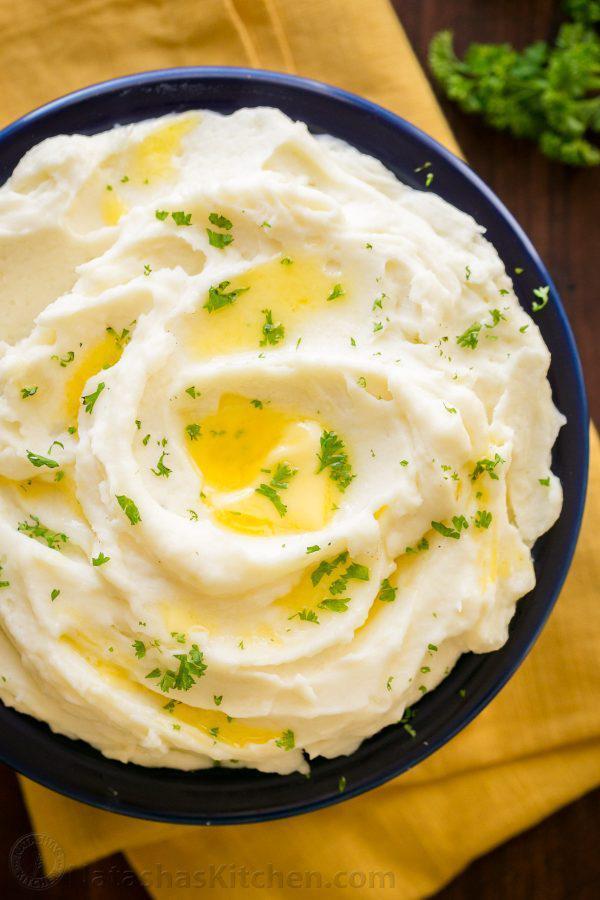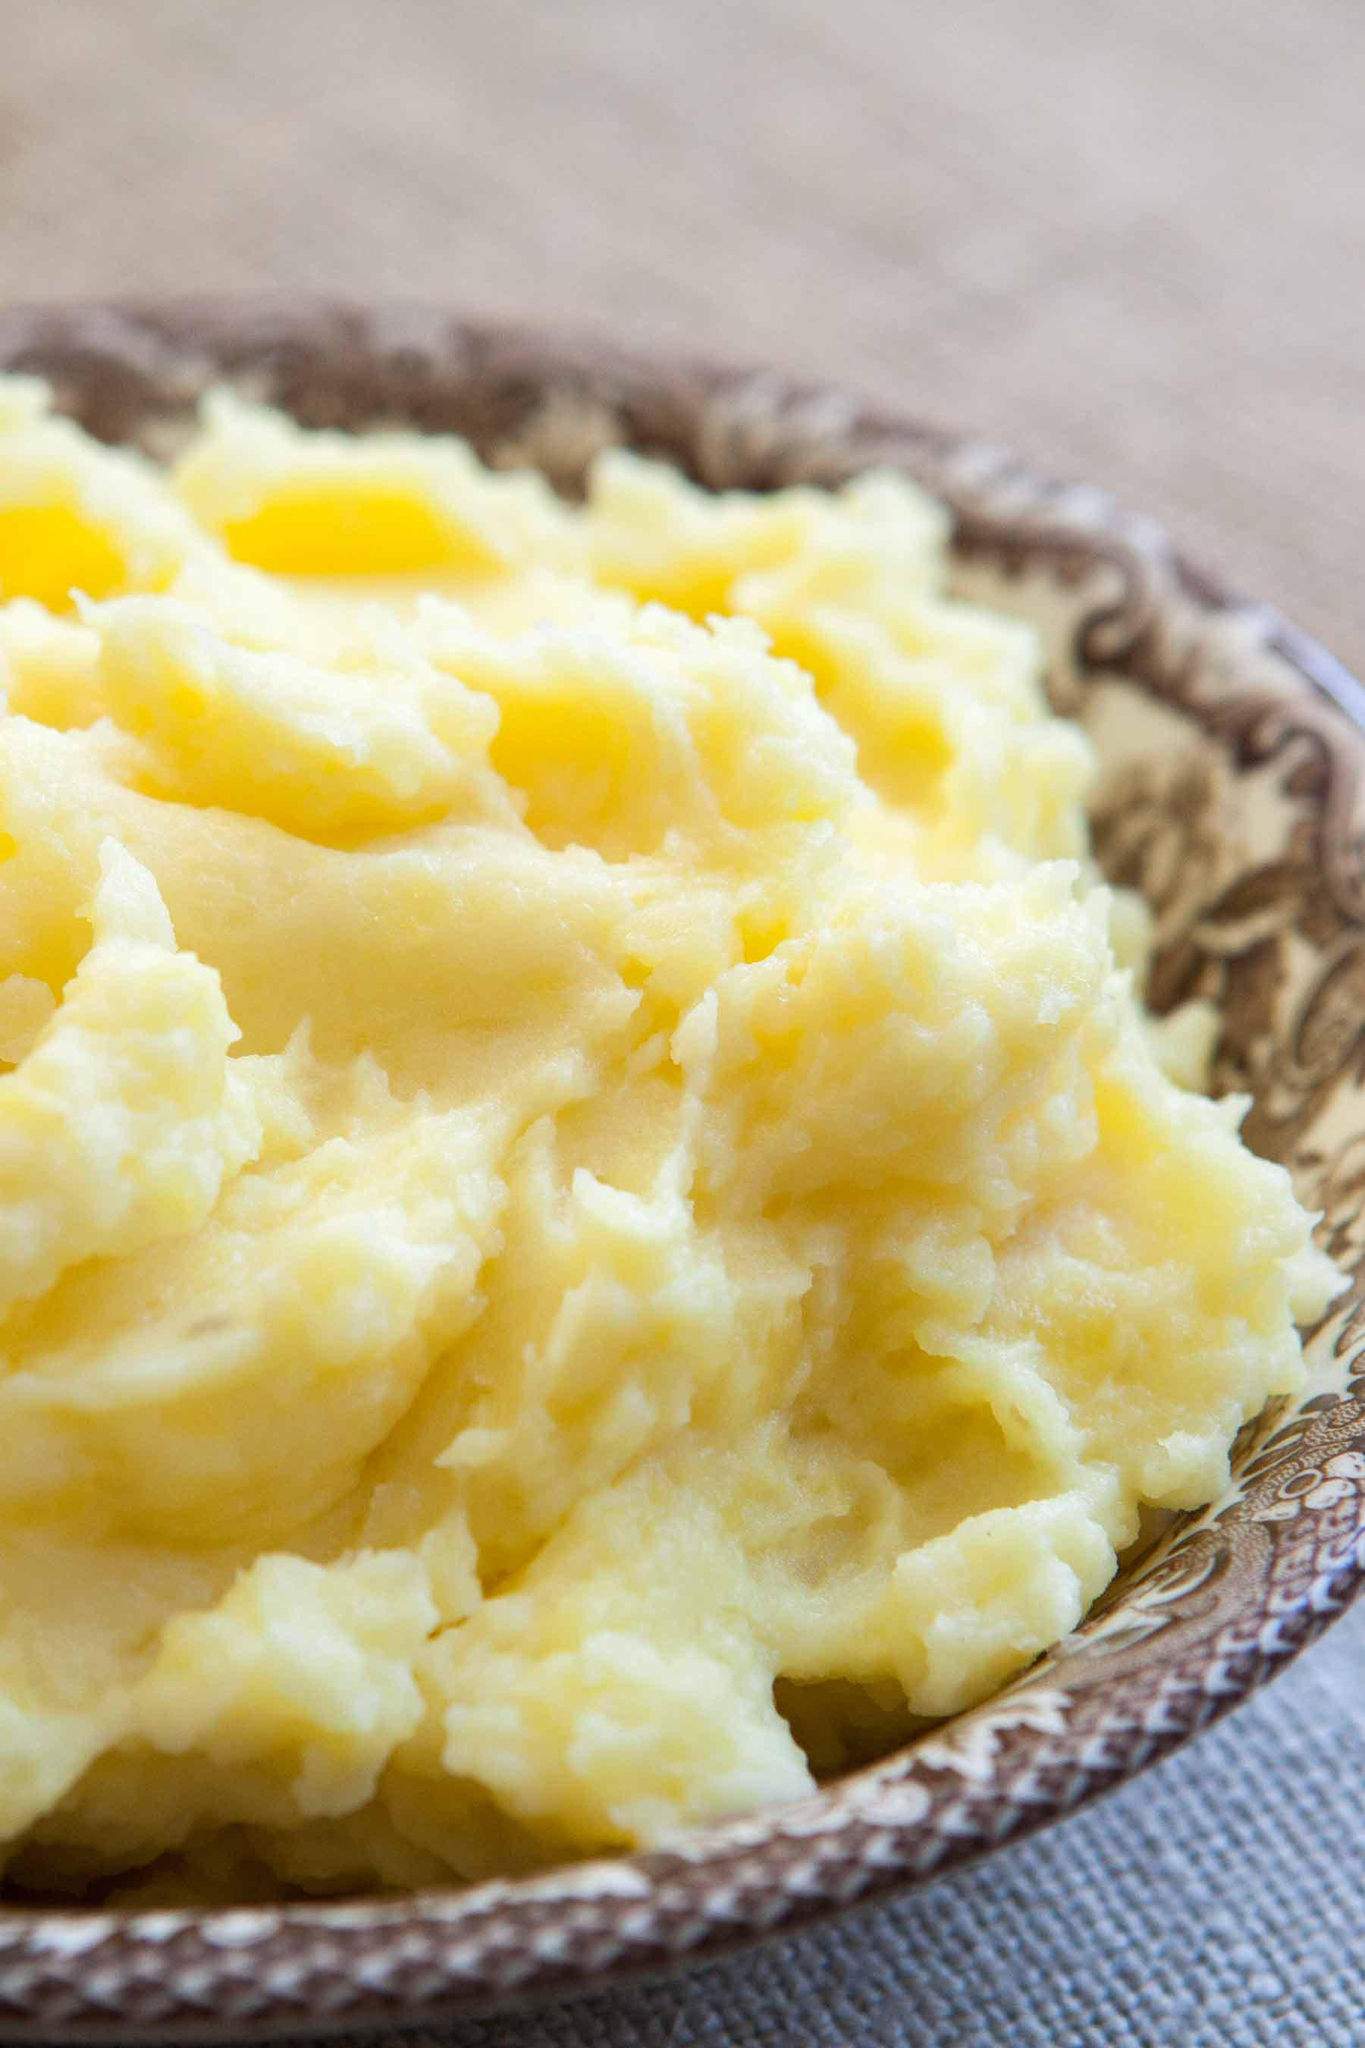The first image is the image on the left, the second image is the image on the right. For the images displayed, is the sentence "At least one image shows mashed potatoes served in a white bowl." factually correct? Answer yes or no. No. The first image is the image on the left, the second image is the image on the right. Given the left and right images, does the statement "At least one bowl is white." hold true? Answer yes or no. No. 